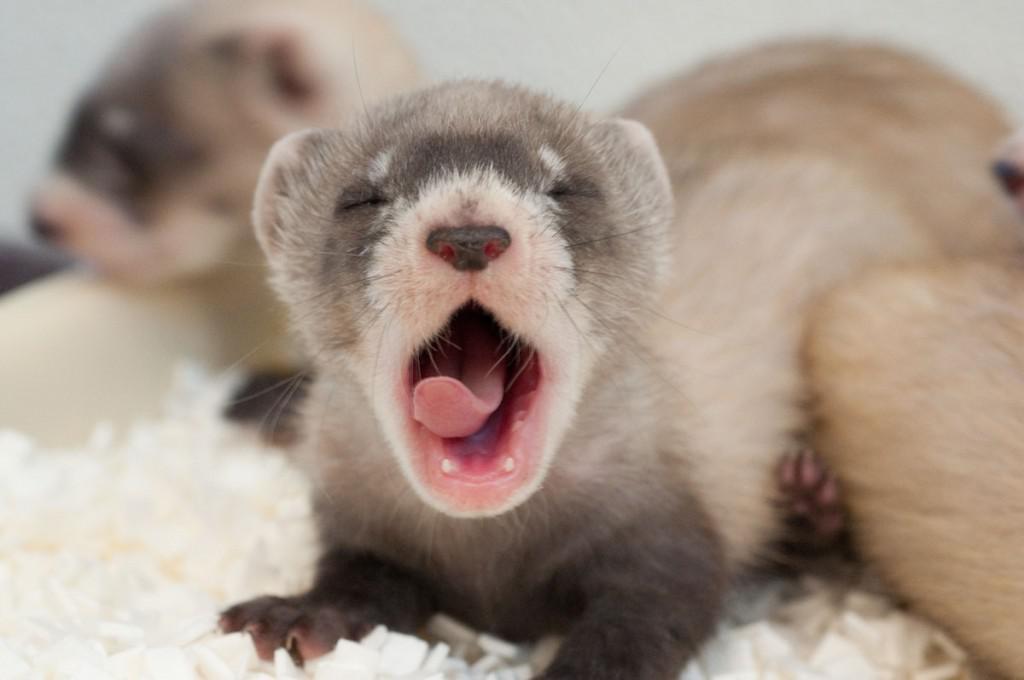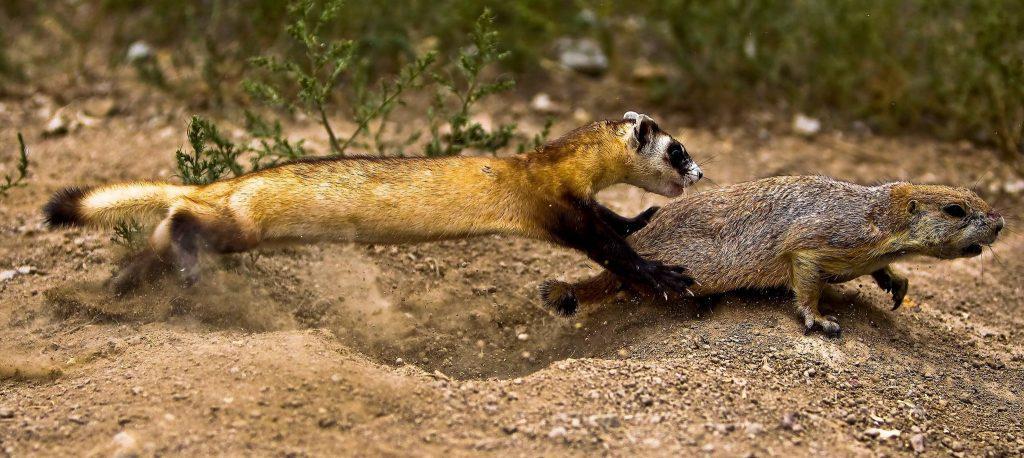The first image is the image on the left, the second image is the image on the right. For the images displayed, is the sentence "An animal is looking to the left." factually correct? Answer yes or no. No. The first image is the image on the left, the second image is the image on the right. Given the left and right images, does the statement "Right and left images show ferrets with heads facing the same direction." hold true? Answer yes or no. No. 